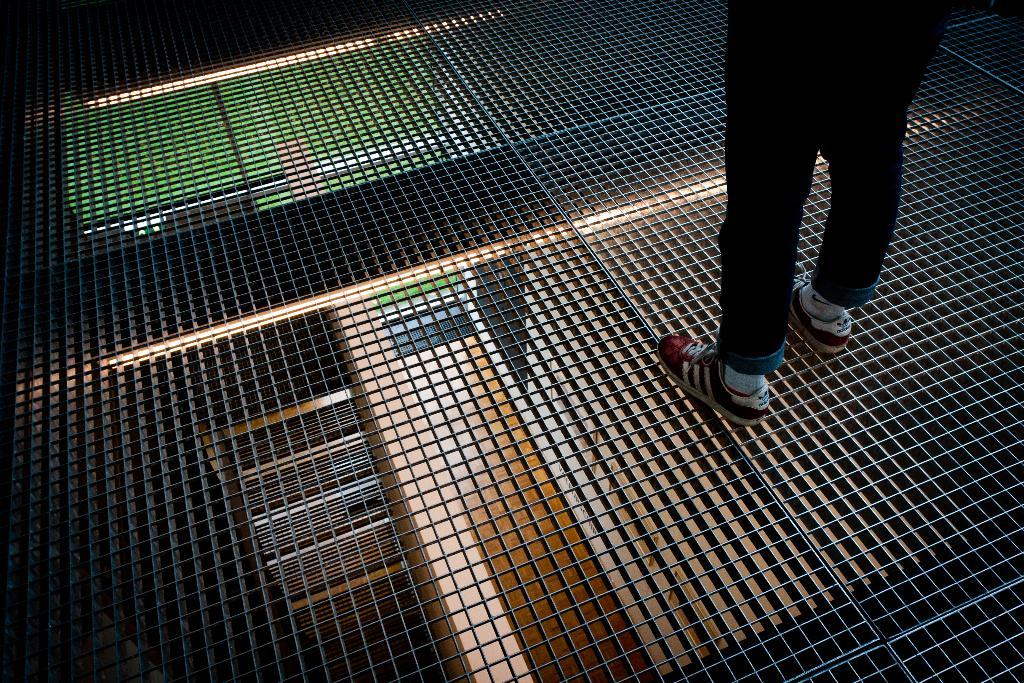Who or what is present in the image? There is a person in the image. What is the person standing on? The person is standing on a mesh. What type of wren can be seen perched on the person's shoulder in the image? There is no wren present in the image; the person is standing on a mesh without any other visible creatures. 